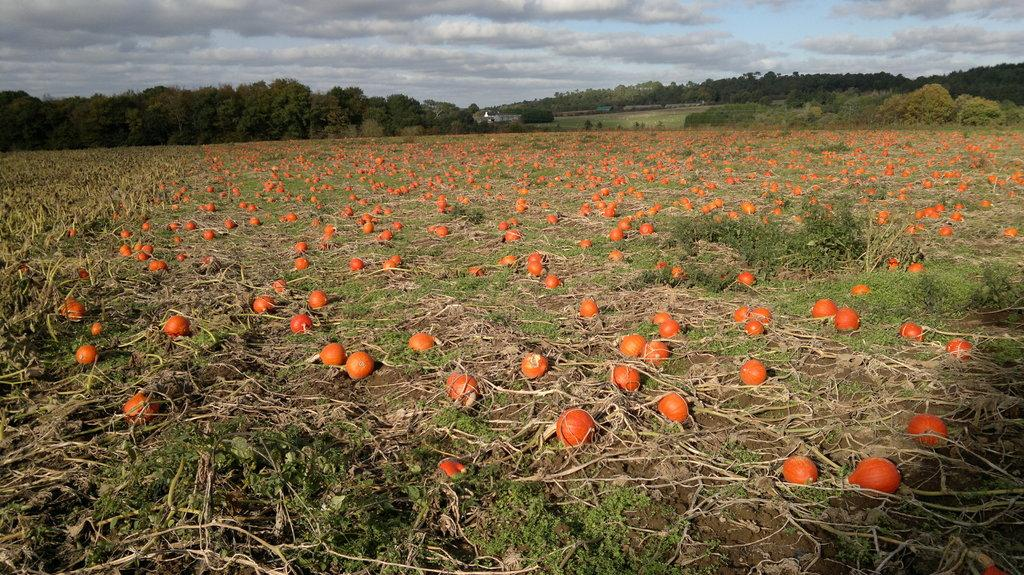What type of food items can be seen in the image? There are vegetables in the image. What type of vegetation is present in the image? There is grass, plants, and trees in the image. What part of the natural environment is visible in the image? The sky is visible in the image. What type of scent can be detected from the vegetables in the image? There is no indication of a scent in the image, as it is a visual representation. --- 